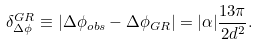Convert formula to latex. <formula><loc_0><loc_0><loc_500><loc_500>\delta ^ { G R } _ { \Delta \phi } \equiv | \Delta \phi _ { o b s } - \Delta \phi _ { G R } | = | \alpha | \frac { 1 3 \pi } { 2 d ^ { 2 } } .</formula> 